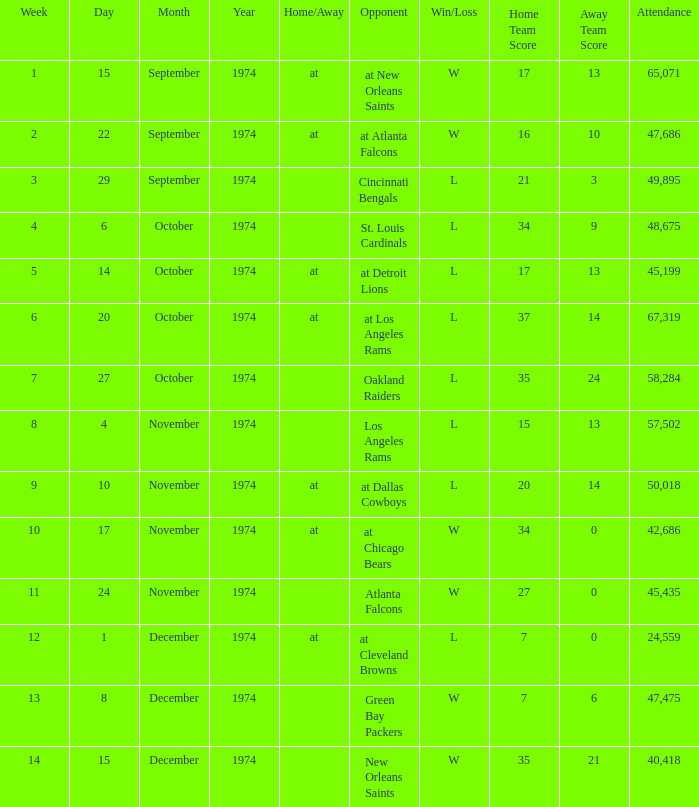What was the result before week 13 when they played the Oakland Raiders? L 35-24. 